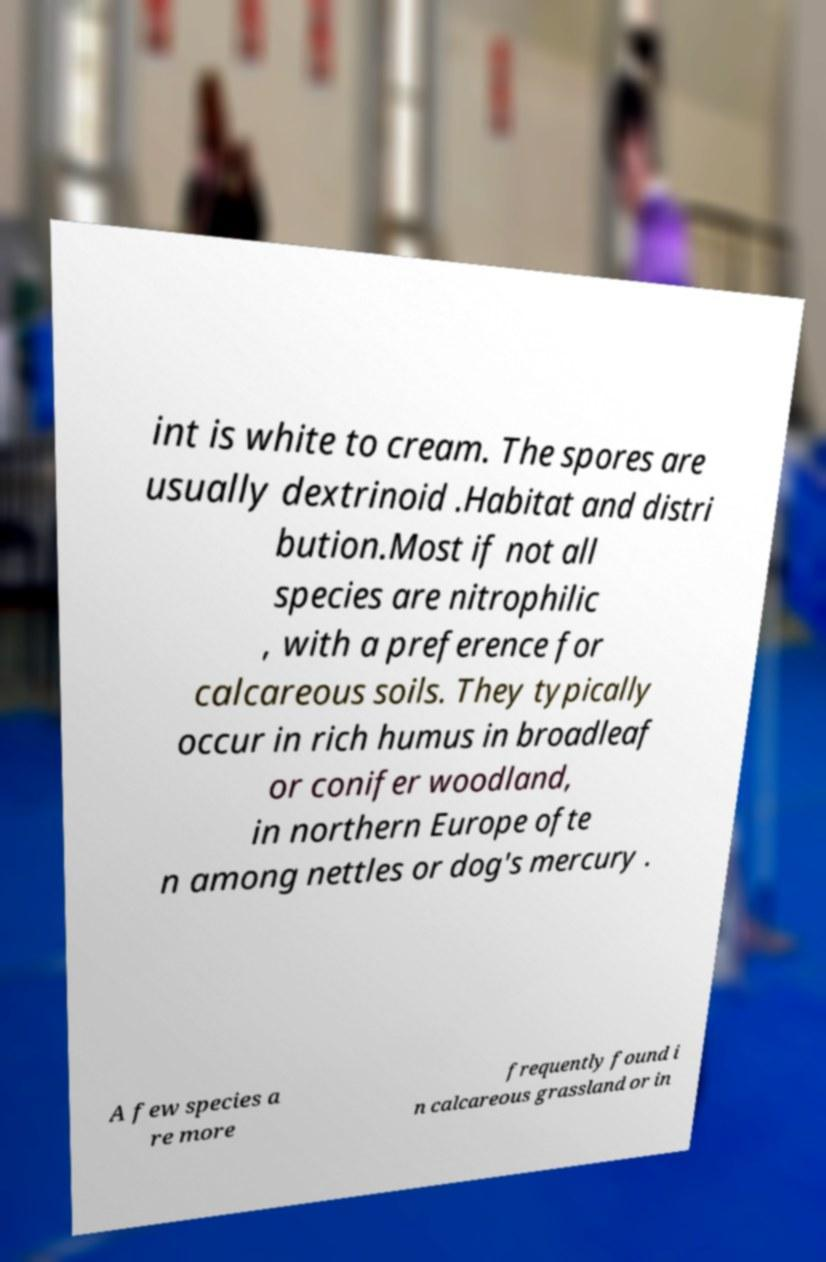I need the written content from this picture converted into text. Can you do that? int is white to cream. The spores are usually dextrinoid .Habitat and distri bution.Most if not all species are nitrophilic , with a preference for calcareous soils. They typically occur in rich humus in broadleaf or conifer woodland, in northern Europe ofte n among nettles or dog's mercury . A few species a re more frequently found i n calcareous grassland or in 